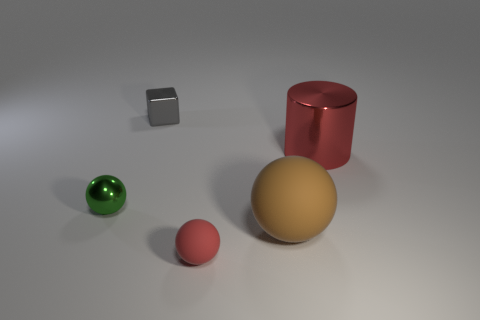What number of purple things are either rubber things or small metal balls?
Your answer should be compact. 0. There is a red thing behind the tiny ball that is on the left side of the tiny red ball; are there any small shiny things in front of it?
Provide a short and direct response. Yes. Are there fewer tiny gray metal cubes than red objects?
Your answer should be very brief. Yes. Does the red object left of the red cylinder have the same shape as the tiny green metal thing?
Ensure brevity in your answer.  Yes. Are any large red shiny cylinders visible?
Your response must be concise. Yes. There is a object behind the red object behind the rubber thing that is on the left side of the big brown sphere; what color is it?
Give a very brief answer. Gray. Are there the same number of things that are behind the big red metallic cylinder and large things behind the tiny shiny ball?
Ensure brevity in your answer.  Yes. The red object that is the same size as the brown ball is what shape?
Keep it short and to the point. Cylinder. Are there any small rubber things of the same color as the large shiny cylinder?
Provide a short and direct response. Yes. What shape is the object on the right side of the big brown object?
Offer a very short reply. Cylinder. 